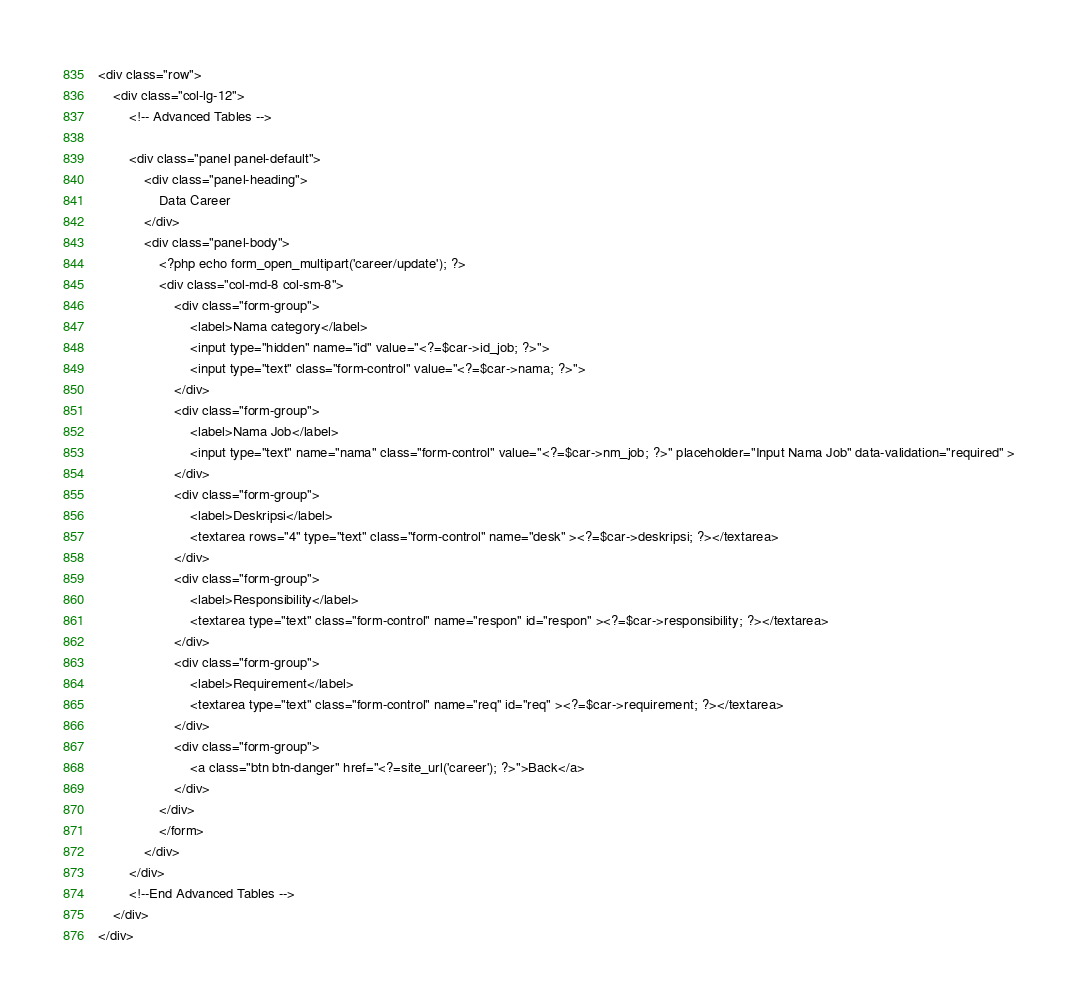Convert code to text. <code><loc_0><loc_0><loc_500><loc_500><_PHP_><div class="row">
	<div class="col-lg-12">
		<!-- Advanced Tables -->

		<div class="panel panel-default">
			<div class="panel-heading">
				Data Career
			</div>
			<div class="panel-body">
				<?php echo form_open_multipart('career/update'); ?>
				<div class="col-md-8 col-sm-8">
					<div class="form-group">
						<label>Nama category</label>
						<input type="hidden" name="id" value="<?=$car->id_job; ?>">
						<input type="text" class="form-control" value="<?=$car->nama; ?>">
					</div>
					<div class="form-group">
						<label>Nama Job</label>
						<input type="text" name="nama" class="form-control" value="<?=$car->nm_job; ?>" placeholder="Input Nama Job" data-validation="required" >
					</div>
					<div class="form-group">
						<label>Deskripsi</label>
						<textarea rows="4" type="text" class="form-control" name="desk" ><?=$car->deskripsi; ?></textarea>
					</div>
					<div class="form-group">
						<label>Responsibility</label>
						<textarea type="text" class="form-control" name="respon" id="respon" ><?=$car->responsibility; ?></textarea>
					</div>
					<div class="form-group">
						<label>Requirement</label>
						<textarea type="text" class="form-control" name="req" id="req" ><?=$car->requirement; ?></textarea>
					</div>
					<div class="form-group">
						<a class="btn btn-danger" href="<?=site_url('career'); ?>">Back</a>
					</div>
				</div>
				</form>
			</div>
		</div>
		<!--End Advanced Tables -->
	</div>
</div>
</code> 